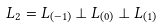Convert formula to latex. <formula><loc_0><loc_0><loc_500><loc_500>L _ { 2 } = L _ { ( { - 1 } ) } \perp L _ { ( { 0 } ) } \perp L _ { ( { 1 } ) }</formula> 